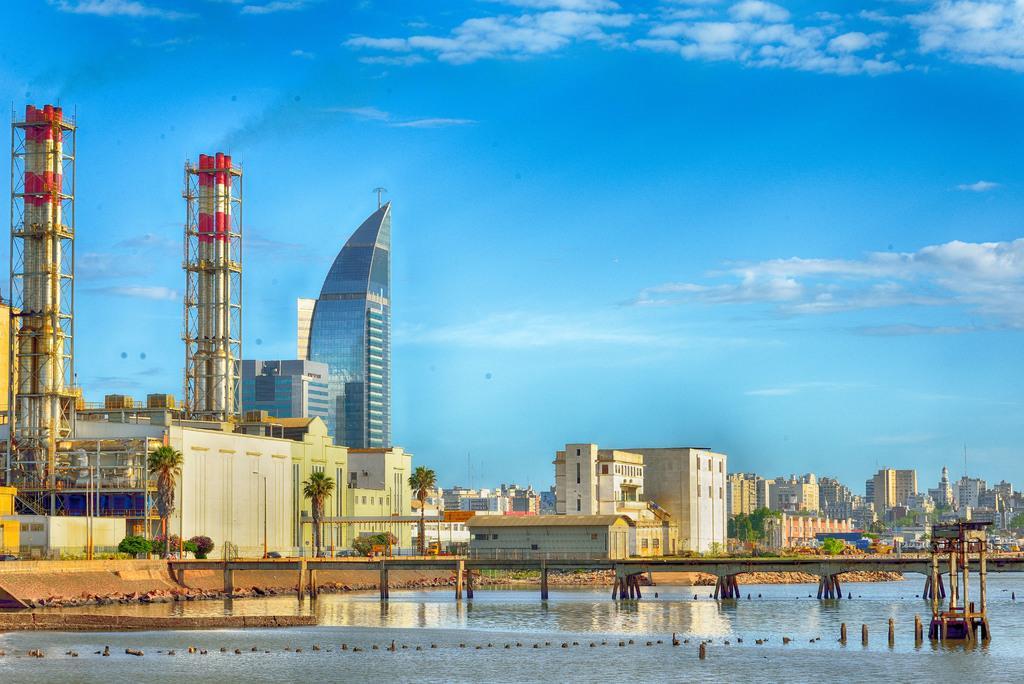Please provide a concise description of this image. This is an outside view. At the bottom, I can see the water. On the right side there is a bridge. In the background there are many buildings and trees. At the top of the image I can see the sky and clouds. 